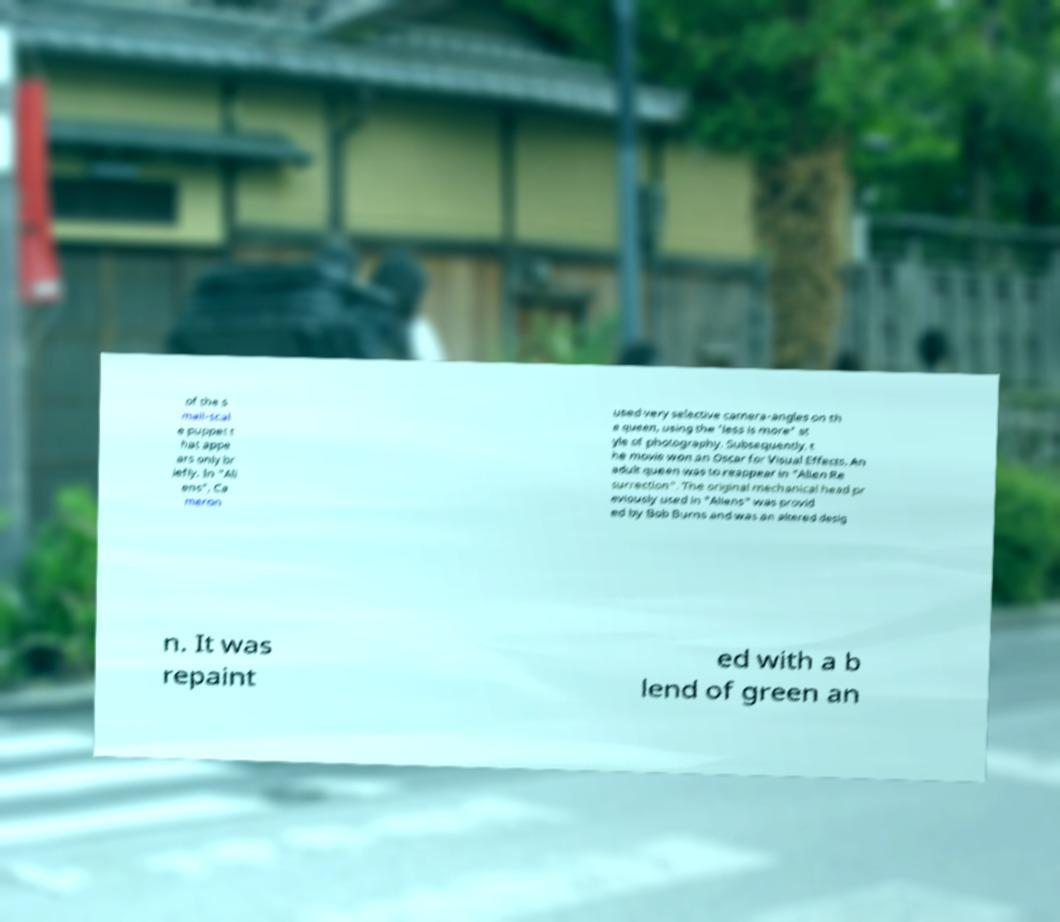Can you read and provide the text displayed in the image?This photo seems to have some interesting text. Can you extract and type it out for me? of the s mall-scal e puppet t hat appe ars only br iefly. In "Ali ens", Ca meron used very selective camera-angles on th e queen, using the 'less is more' st yle of photography. Subsequently, t he movie won an Oscar for Visual Effects. An adult queen was to reappear in "Alien Re surrection". The original mechanical head pr eviously used in "Aliens" was provid ed by Bob Burns and was an altered desig n. It was repaint ed with a b lend of green an 